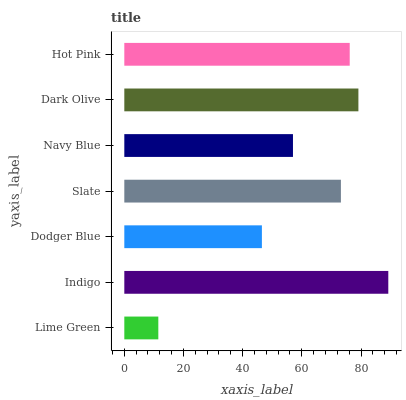Is Lime Green the minimum?
Answer yes or no. Yes. Is Indigo the maximum?
Answer yes or no. Yes. Is Dodger Blue the minimum?
Answer yes or no. No. Is Dodger Blue the maximum?
Answer yes or no. No. Is Indigo greater than Dodger Blue?
Answer yes or no. Yes. Is Dodger Blue less than Indigo?
Answer yes or no. Yes. Is Dodger Blue greater than Indigo?
Answer yes or no. No. Is Indigo less than Dodger Blue?
Answer yes or no. No. Is Slate the high median?
Answer yes or no. Yes. Is Slate the low median?
Answer yes or no. Yes. Is Dark Olive the high median?
Answer yes or no. No. Is Navy Blue the low median?
Answer yes or no. No. 